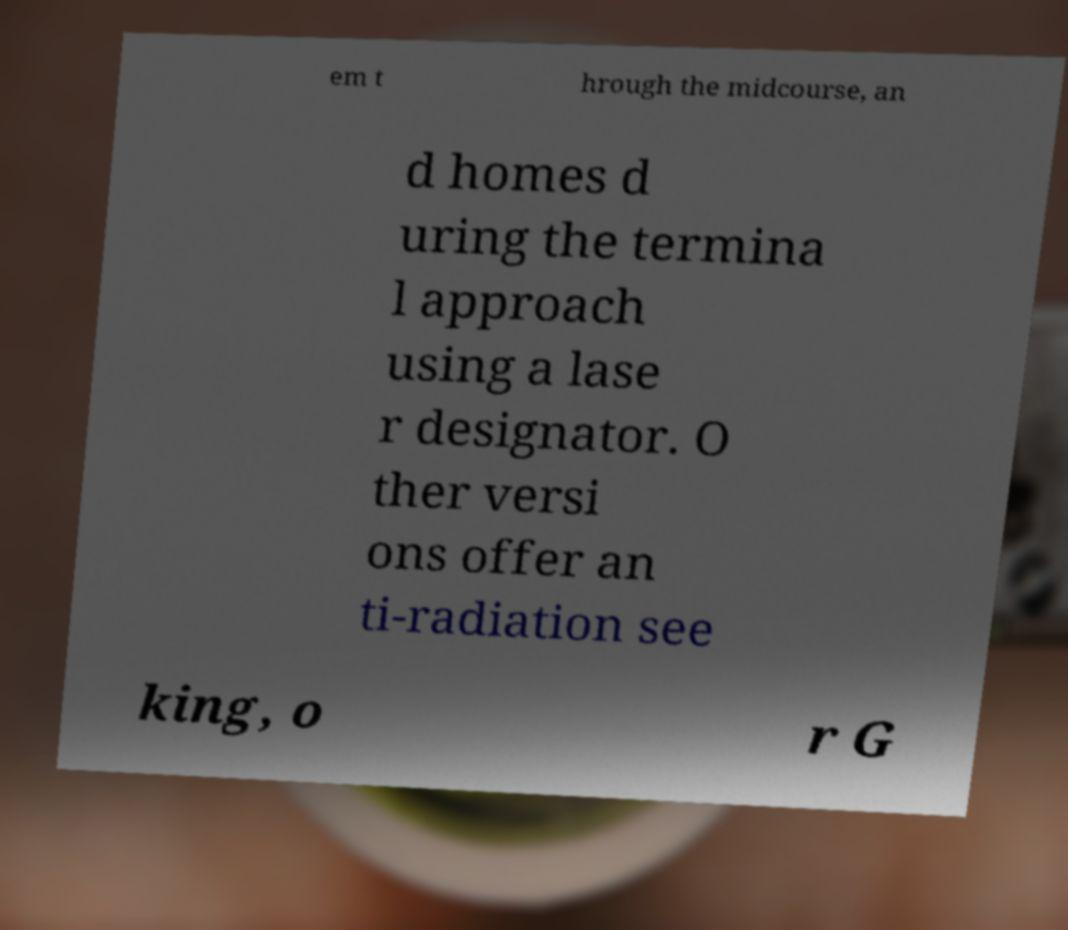For documentation purposes, I need the text within this image transcribed. Could you provide that? em t hrough the midcourse, an d homes d uring the termina l approach using a lase r designator. O ther versi ons offer an ti-radiation see king, o r G 